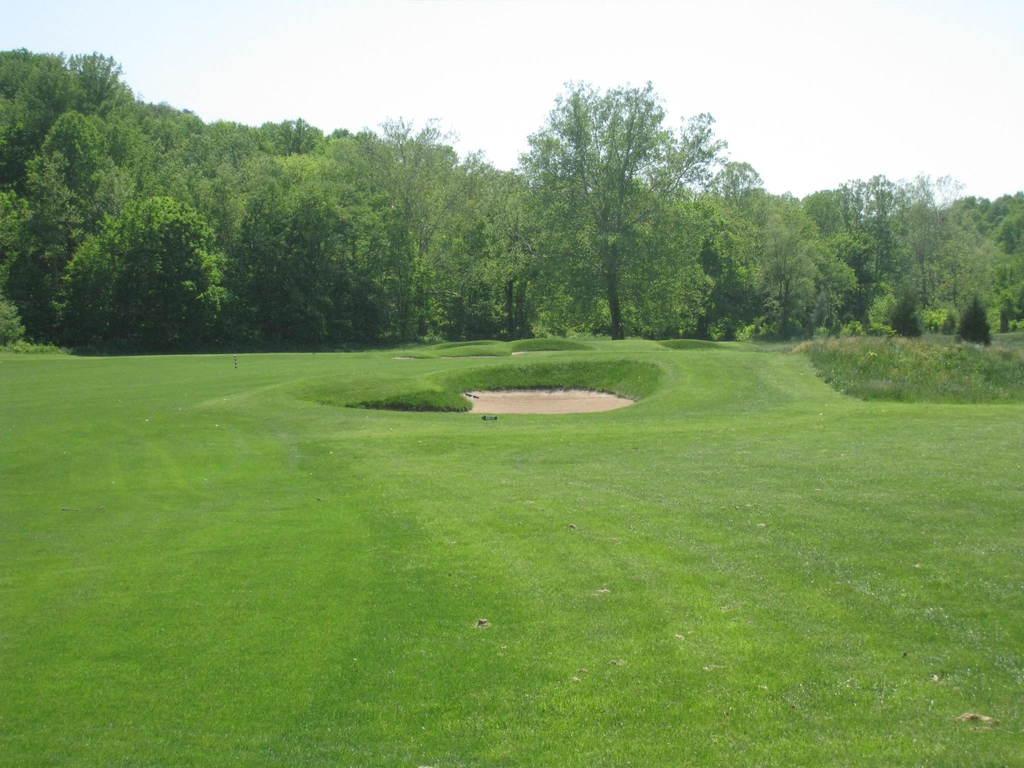Could you give a brief overview of what you see in this image? In this image there is the sky towards the top of the image, there are trees, there are plants towards the right of the image, there is grass towards the bottom of the image. 